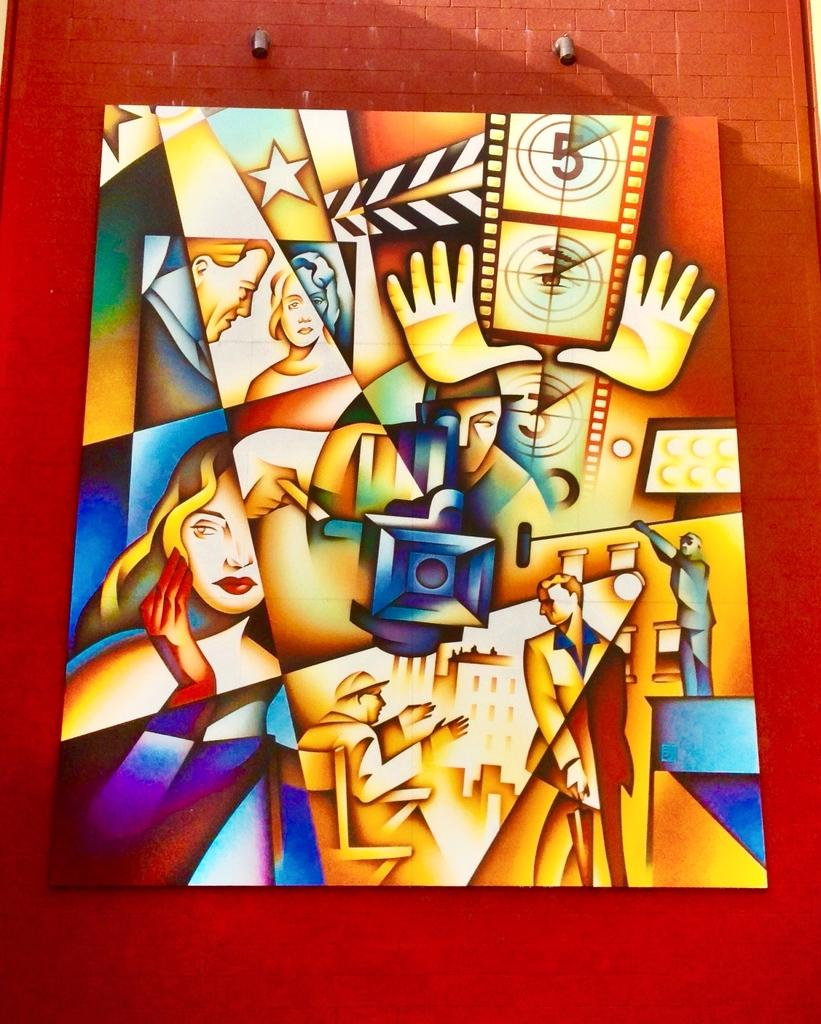What is the main object in the image? There is a frame in the image. Where is the frame located? The frame is attached to a wall. What is inside the frame? The frame appears to contain a painting. What is the color of the wall the frame is attached to? The wall is red in color. What type of record is playing in the background of the image? There is no record playing in the background of the image; it only features a frame attached to a red wall. 